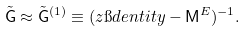Convert formula to latex. <formula><loc_0><loc_0><loc_500><loc_500>\tilde { \mathsf G } \approx \tilde { \mathsf G } ^ { ( 1 ) } \equiv ( z \i d e n t i t y - \mathsf M ^ { E } ) ^ { - 1 } .</formula> 